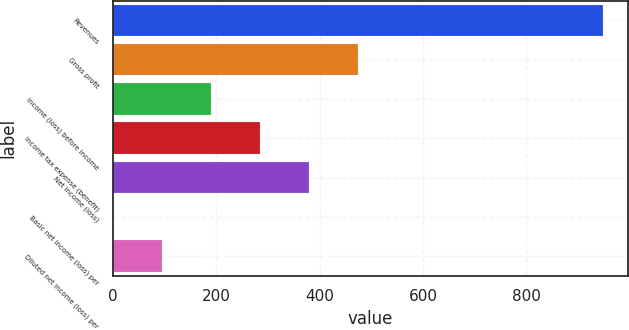Convert chart to OTSL. <chart><loc_0><loc_0><loc_500><loc_500><bar_chart><fcel>Revenues<fcel>Gross profit<fcel>Income (loss) before income<fcel>Income tax expense (benefit)<fcel>Net income (loss)<fcel>Basic net income (loss) per<fcel>Diluted net income (loss) per<nl><fcel>948.4<fcel>474.23<fcel>189.71<fcel>284.55<fcel>379.39<fcel>0.03<fcel>94.87<nl></chart> 